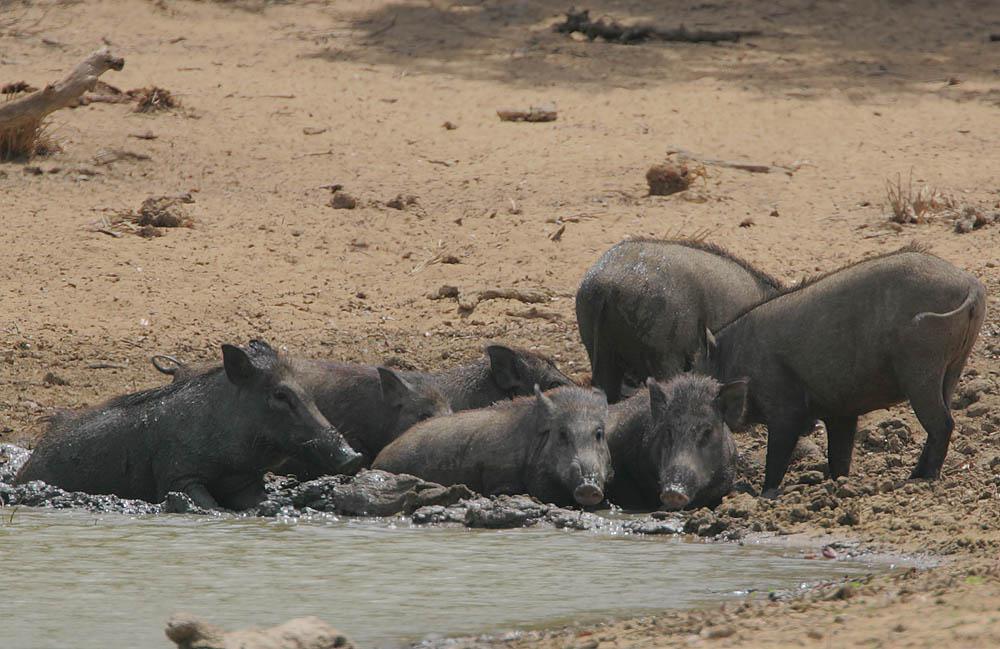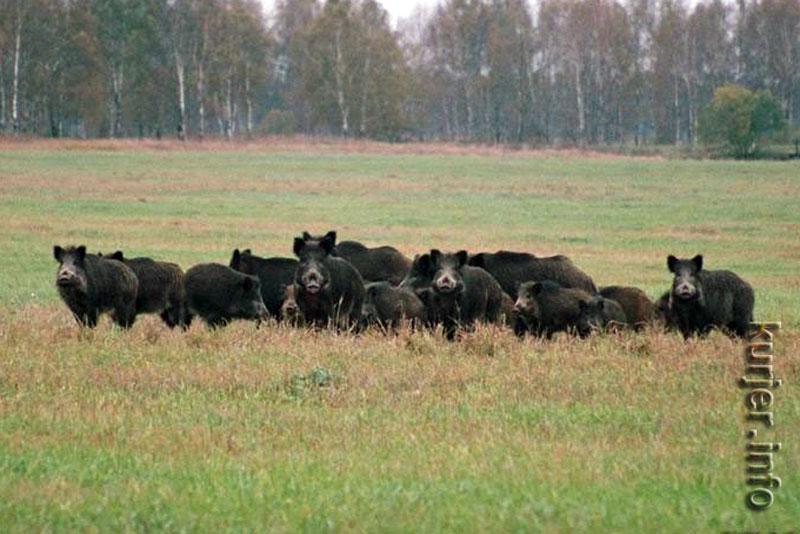The first image is the image on the left, the second image is the image on the right. For the images shown, is this caption "there are no more than three boars in one of the images" true? Answer yes or no. No. 